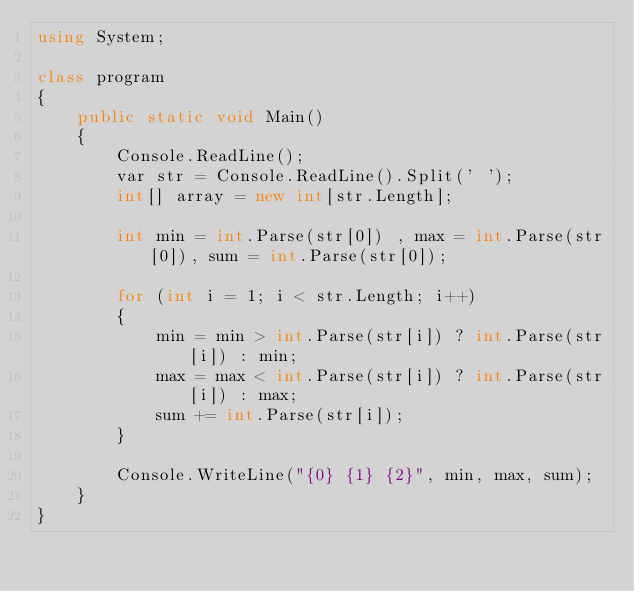Convert code to text. <code><loc_0><loc_0><loc_500><loc_500><_C#_>using System;

class program
{
    public static void Main()
    {
        Console.ReadLine();
        var str = Console.ReadLine().Split(' ');
        int[] array = new int[str.Length];

        int min = int.Parse(str[0]) , max = int.Parse(str[0]), sum = int.Parse(str[0]);
        
        for (int i = 1; i < str.Length; i++)
        {
            min = min > int.Parse(str[i]) ? int.Parse(str[i]) : min;
            max = max < int.Parse(str[i]) ? int.Parse(str[i]) : max;
            sum += int.Parse(str[i]);
        }

        Console.WriteLine("{0} {1} {2}", min, max, sum);
    }
}</code> 